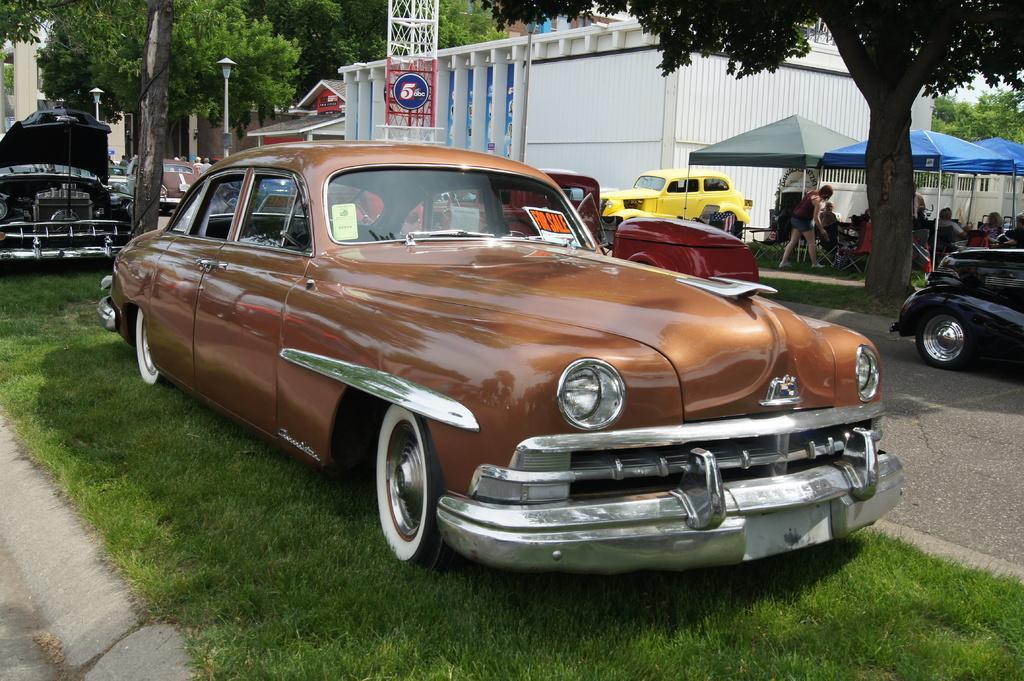Can you describe this image briefly? In this image we can see vehicles. On the right there are tents and we can see a building. In the background there are trees, poles and sky. At the bottom there is grass and we can see people. 